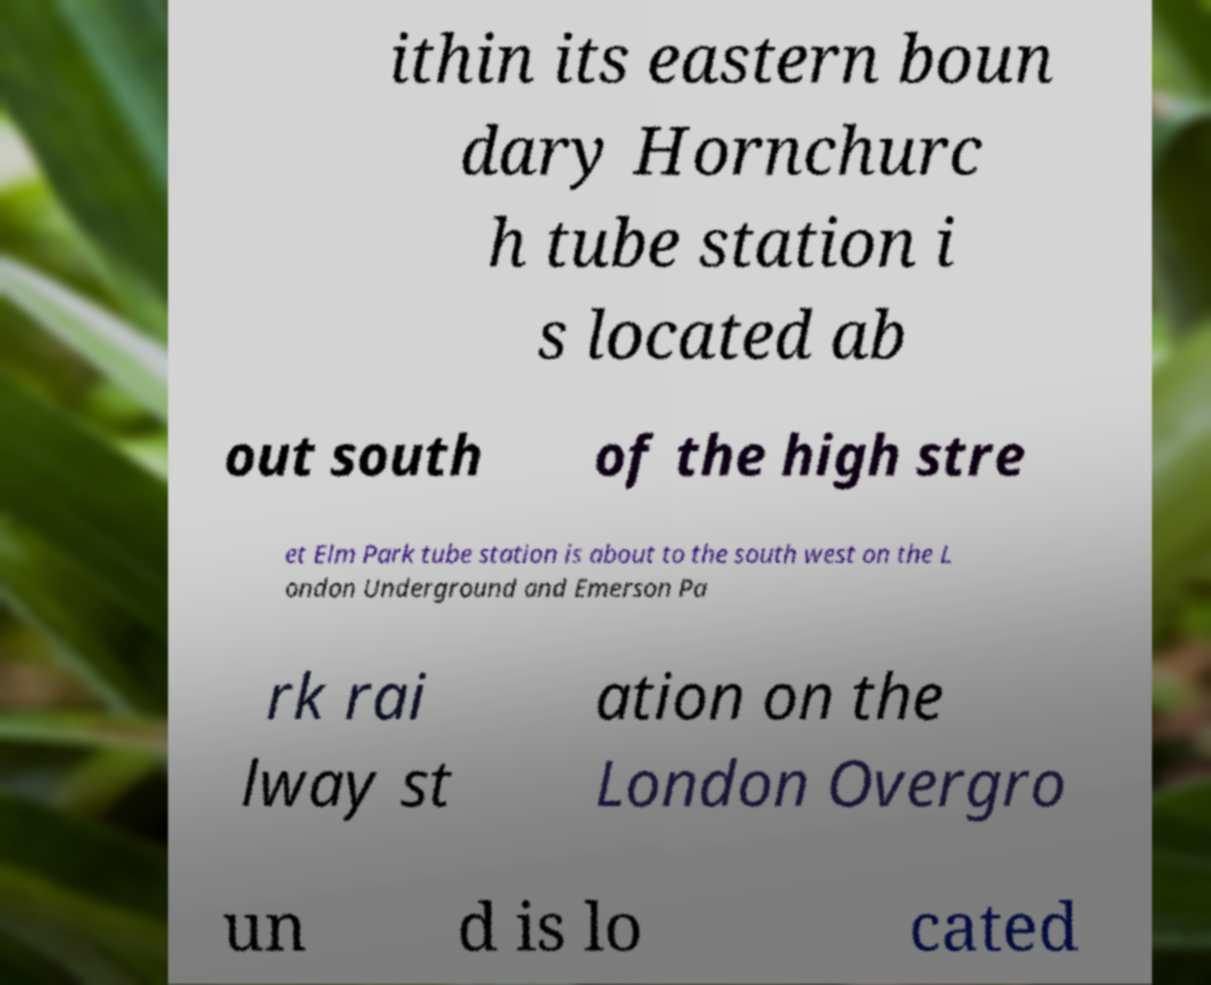Could you assist in decoding the text presented in this image and type it out clearly? ithin its eastern boun dary Hornchurc h tube station i s located ab out south of the high stre et Elm Park tube station is about to the south west on the L ondon Underground and Emerson Pa rk rai lway st ation on the London Overgro un d is lo cated 